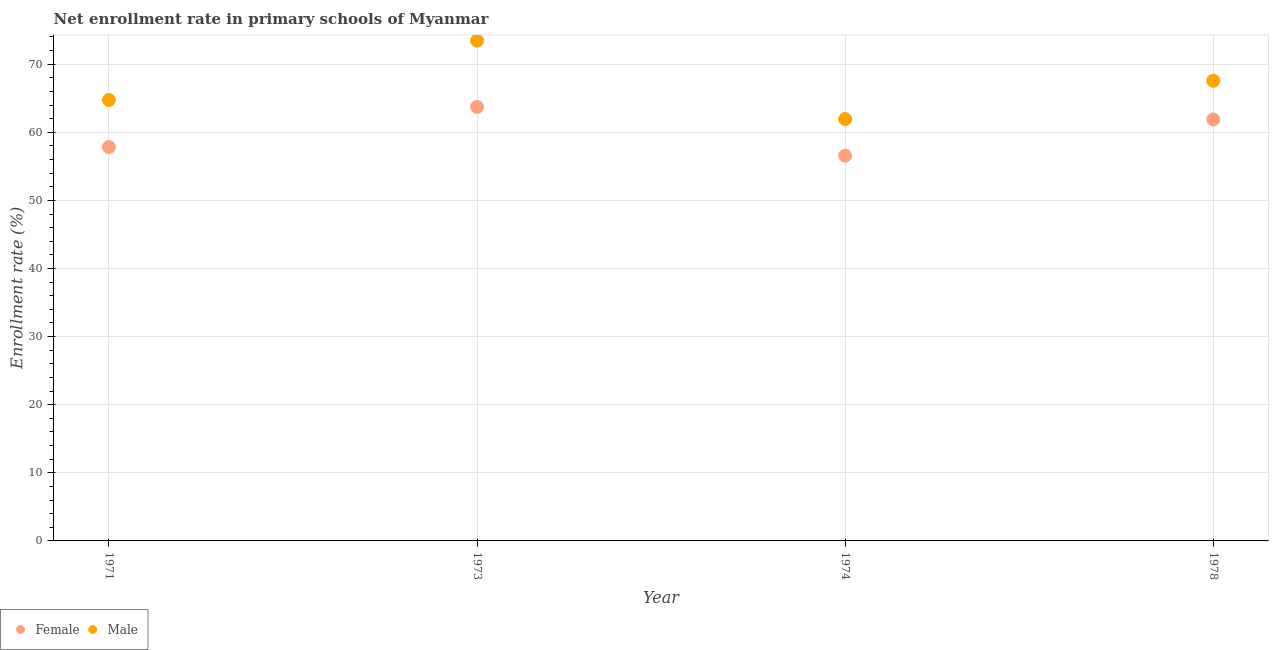How many different coloured dotlines are there?
Make the answer very short. 2. Is the number of dotlines equal to the number of legend labels?
Keep it short and to the point. Yes. What is the enrollment rate of female students in 1978?
Your response must be concise. 61.89. Across all years, what is the maximum enrollment rate of male students?
Your answer should be compact. 73.46. Across all years, what is the minimum enrollment rate of male students?
Keep it short and to the point. 61.95. In which year was the enrollment rate of male students maximum?
Keep it short and to the point. 1973. In which year was the enrollment rate of male students minimum?
Keep it short and to the point. 1974. What is the total enrollment rate of male students in the graph?
Offer a very short reply. 267.71. What is the difference between the enrollment rate of female students in 1973 and that in 1978?
Your response must be concise. 1.83. What is the difference between the enrollment rate of female students in 1973 and the enrollment rate of male students in 1971?
Provide a short and direct response. -1.01. What is the average enrollment rate of female students per year?
Keep it short and to the point. 60. In the year 1973, what is the difference between the enrollment rate of female students and enrollment rate of male students?
Make the answer very short. -9.73. In how many years, is the enrollment rate of female students greater than 12 %?
Provide a succinct answer. 4. What is the ratio of the enrollment rate of female students in 1973 to that in 1978?
Give a very brief answer. 1.03. Is the difference between the enrollment rate of male students in 1974 and 1978 greater than the difference between the enrollment rate of female students in 1974 and 1978?
Offer a very short reply. No. What is the difference between the highest and the second highest enrollment rate of female students?
Offer a very short reply. 1.83. What is the difference between the highest and the lowest enrollment rate of male students?
Ensure brevity in your answer.  11.51. Is the enrollment rate of male students strictly less than the enrollment rate of female students over the years?
Provide a short and direct response. No. What is the difference between two consecutive major ticks on the Y-axis?
Your response must be concise. 10. Are the values on the major ticks of Y-axis written in scientific E-notation?
Make the answer very short. No. Does the graph contain any zero values?
Your response must be concise. No. Where does the legend appear in the graph?
Offer a very short reply. Bottom left. How are the legend labels stacked?
Offer a very short reply. Horizontal. What is the title of the graph?
Ensure brevity in your answer.  Net enrollment rate in primary schools of Myanmar. What is the label or title of the Y-axis?
Offer a terse response. Enrollment rate (%). What is the Enrollment rate (%) in Female in 1971?
Keep it short and to the point. 57.83. What is the Enrollment rate (%) of Male in 1971?
Give a very brief answer. 64.74. What is the Enrollment rate (%) of Female in 1973?
Keep it short and to the point. 63.73. What is the Enrollment rate (%) of Male in 1973?
Your answer should be very brief. 73.46. What is the Enrollment rate (%) of Female in 1974?
Provide a succinct answer. 56.56. What is the Enrollment rate (%) in Male in 1974?
Provide a succinct answer. 61.95. What is the Enrollment rate (%) of Female in 1978?
Your answer should be very brief. 61.89. What is the Enrollment rate (%) in Male in 1978?
Ensure brevity in your answer.  67.57. Across all years, what is the maximum Enrollment rate (%) in Female?
Offer a terse response. 63.73. Across all years, what is the maximum Enrollment rate (%) of Male?
Ensure brevity in your answer.  73.46. Across all years, what is the minimum Enrollment rate (%) in Female?
Provide a succinct answer. 56.56. Across all years, what is the minimum Enrollment rate (%) in Male?
Your answer should be compact. 61.95. What is the total Enrollment rate (%) in Female in the graph?
Give a very brief answer. 240.01. What is the total Enrollment rate (%) of Male in the graph?
Keep it short and to the point. 267.71. What is the difference between the Enrollment rate (%) in Female in 1971 and that in 1973?
Give a very brief answer. -5.89. What is the difference between the Enrollment rate (%) of Male in 1971 and that in 1973?
Your answer should be very brief. -8.72. What is the difference between the Enrollment rate (%) of Female in 1971 and that in 1974?
Offer a terse response. 1.27. What is the difference between the Enrollment rate (%) of Male in 1971 and that in 1974?
Provide a succinct answer. 2.79. What is the difference between the Enrollment rate (%) in Female in 1971 and that in 1978?
Offer a terse response. -4.06. What is the difference between the Enrollment rate (%) of Male in 1971 and that in 1978?
Give a very brief answer. -2.83. What is the difference between the Enrollment rate (%) in Female in 1973 and that in 1974?
Offer a terse response. 7.16. What is the difference between the Enrollment rate (%) in Male in 1973 and that in 1974?
Your answer should be very brief. 11.51. What is the difference between the Enrollment rate (%) in Female in 1973 and that in 1978?
Ensure brevity in your answer.  1.83. What is the difference between the Enrollment rate (%) of Male in 1973 and that in 1978?
Your answer should be compact. 5.89. What is the difference between the Enrollment rate (%) in Female in 1974 and that in 1978?
Provide a succinct answer. -5.33. What is the difference between the Enrollment rate (%) of Male in 1974 and that in 1978?
Your answer should be very brief. -5.62. What is the difference between the Enrollment rate (%) of Female in 1971 and the Enrollment rate (%) of Male in 1973?
Offer a very short reply. -15.62. What is the difference between the Enrollment rate (%) in Female in 1971 and the Enrollment rate (%) in Male in 1974?
Make the answer very short. -4.11. What is the difference between the Enrollment rate (%) in Female in 1971 and the Enrollment rate (%) in Male in 1978?
Provide a succinct answer. -9.73. What is the difference between the Enrollment rate (%) in Female in 1973 and the Enrollment rate (%) in Male in 1974?
Provide a succinct answer. 1.78. What is the difference between the Enrollment rate (%) of Female in 1973 and the Enrollment rate (%) of Male in 1978?
Ensure brevity in your answer.  -3.84. What is the difference between the Enrollment rate (%) of Female in 1974 and the Enrollment rate (%) of Male in 1978?
Offer a terse response. -11. What is the average Enrollment rate (%) of Female per year?
Give a very brief answer. 60. What is the average Enrollment rate (%) in Male per year?
Your answer should be very brief. 66.93. In the year 1971, what is the difference between the Enrollment rate (%) of Female and Enrollment rate (%) of Male?
Offer a terse response. -6.91. In the year 1973, what is the difference between the Enrollment rate (%) of Female and Enrollment rate (%) of Male?
Make the answer very short. -9.73. In the year 1974, what is the difference between the Enrollment rate (%) in Female and Enrollment rate (%) in Male?
Keep it short and to the point. -5.38. In the year 1978, what is the difference between the Enrollment rate (%) in Female and Enrollment rate (%) in Male?
Your answer should be compact. -5.67. What is the ratio of the Enrollment rate (%) of Female in 1971 to that in 1973?
Your response must be concise. 0.91. What is the ratio of the Enrollment rate (%) in Male in 1971 to that in 1973?
Give a very brief answer. 0.88. What is the ratio of the Enrollment rate (%) in Female in 1971 to that in 1974?
Your response must be concise. 1.02. What is the ratio of the Enrollment rate (%) in Male in 1971 to that in 1974?
Make the answer very short. 1.05. What is the ratio of the Enrollment rate (%) in Female in 1971 to that in 1978?
Provide a short and direct response. 0.93. What is the ratio of the Enrollment rate (%) of Male in 1971 to that in 1978?
Keep it short and to the point. 0.96. What is the ratio of the Enrollment rate (%) in Female in 1973 to that in 1974?
Offer a terse response. 1.13. What is the ratio of the Enrollment rate (%) in Male in 1973 to that in 1974?
Make the answer very short. 1.19. What is the ratio of the Enrollment rate (%) of Female in 1973 to that in 1978?
Ensure brevity in your answer.  1.03. What is the ratio of the Enrollment rate (%) in Male in 1973 to that in 1978?
Ensure brevity in your answer.  1.09. What is the ratio of the Enrollment rate (%) in Female in 1974 to that in 1978?
Provide a short and direct response. 0.91. What is the ratio of the Enrollment rate (%) in Male in 1974 to that in 1978?
Your answer should be very brief. 0.92. What is the difference between the highest and the second highest Enrollment rate (%) of Female?
Your answer should be compact. 1.83. What is the difference between the highest and the second highest Enrollment rate (%) of Male?
Your answer should be very brief. 5.89. What is the difference between the highest and the lowest Enrollment rate (%) in Female?
Offer a terse response. 7.16. What is the difference between the highest and the lowest Enrollment rate (%) of Male?
Provide a short and direct response. 11.51. 